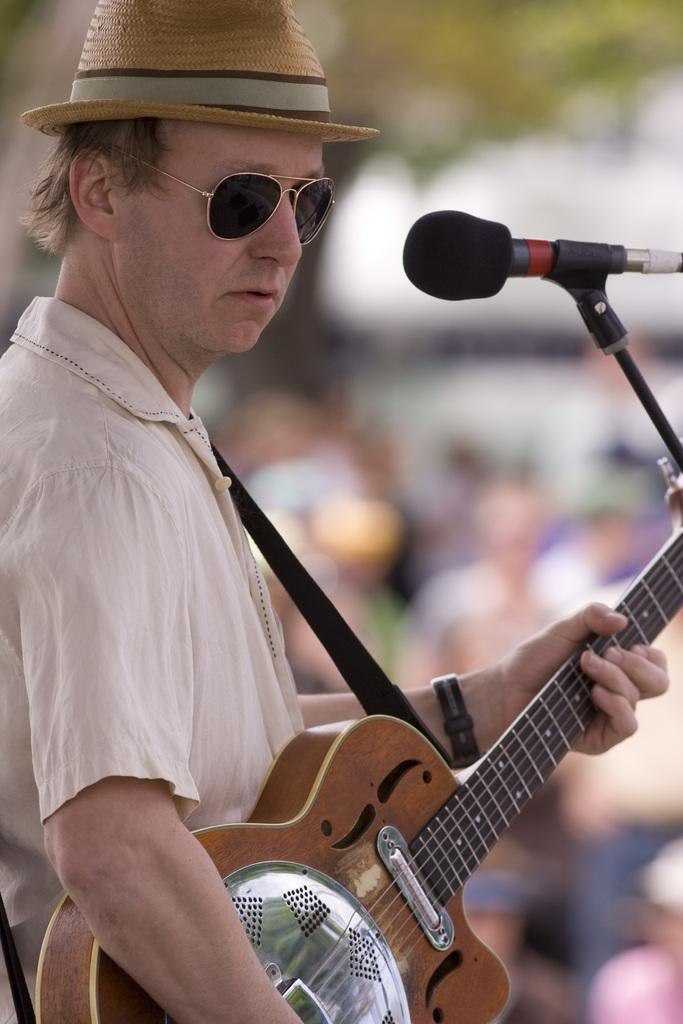Who is the main subject in the image? There is a man in the image. What is the man holding in the image? The man is holding a guitar. What other object is present in the image? There is a microphone in the image. Can you describe the setting of the image? There are people visible in the background of the image. What type of flowers can be seen in the image? There are no flowers present in the image. Is there a carriage visible in the image? There is no carriage present in the image. 